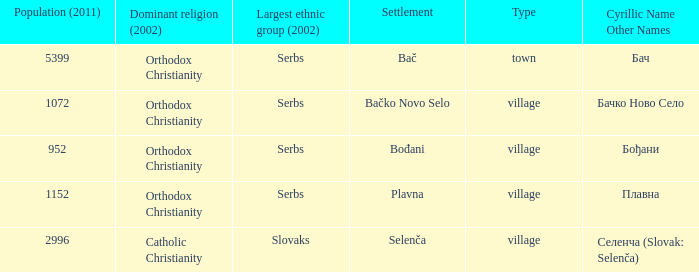What is the smallest population listed? 952.0. 